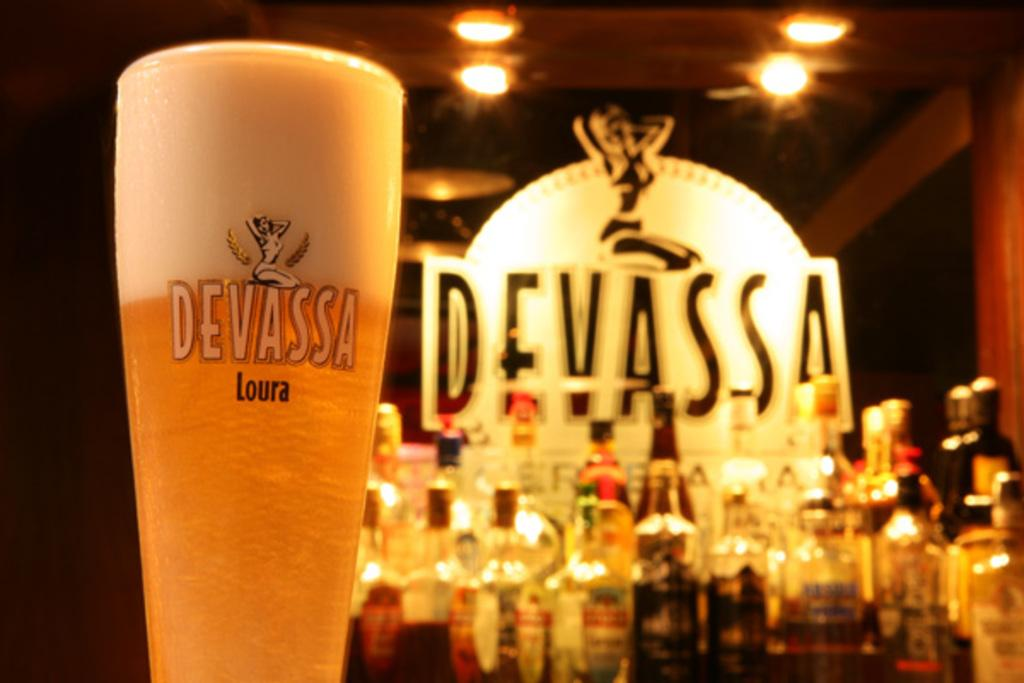<image>
Create a compact narrative representing the image presented. Cup of beer in front of a sign that says DEVASSA. 